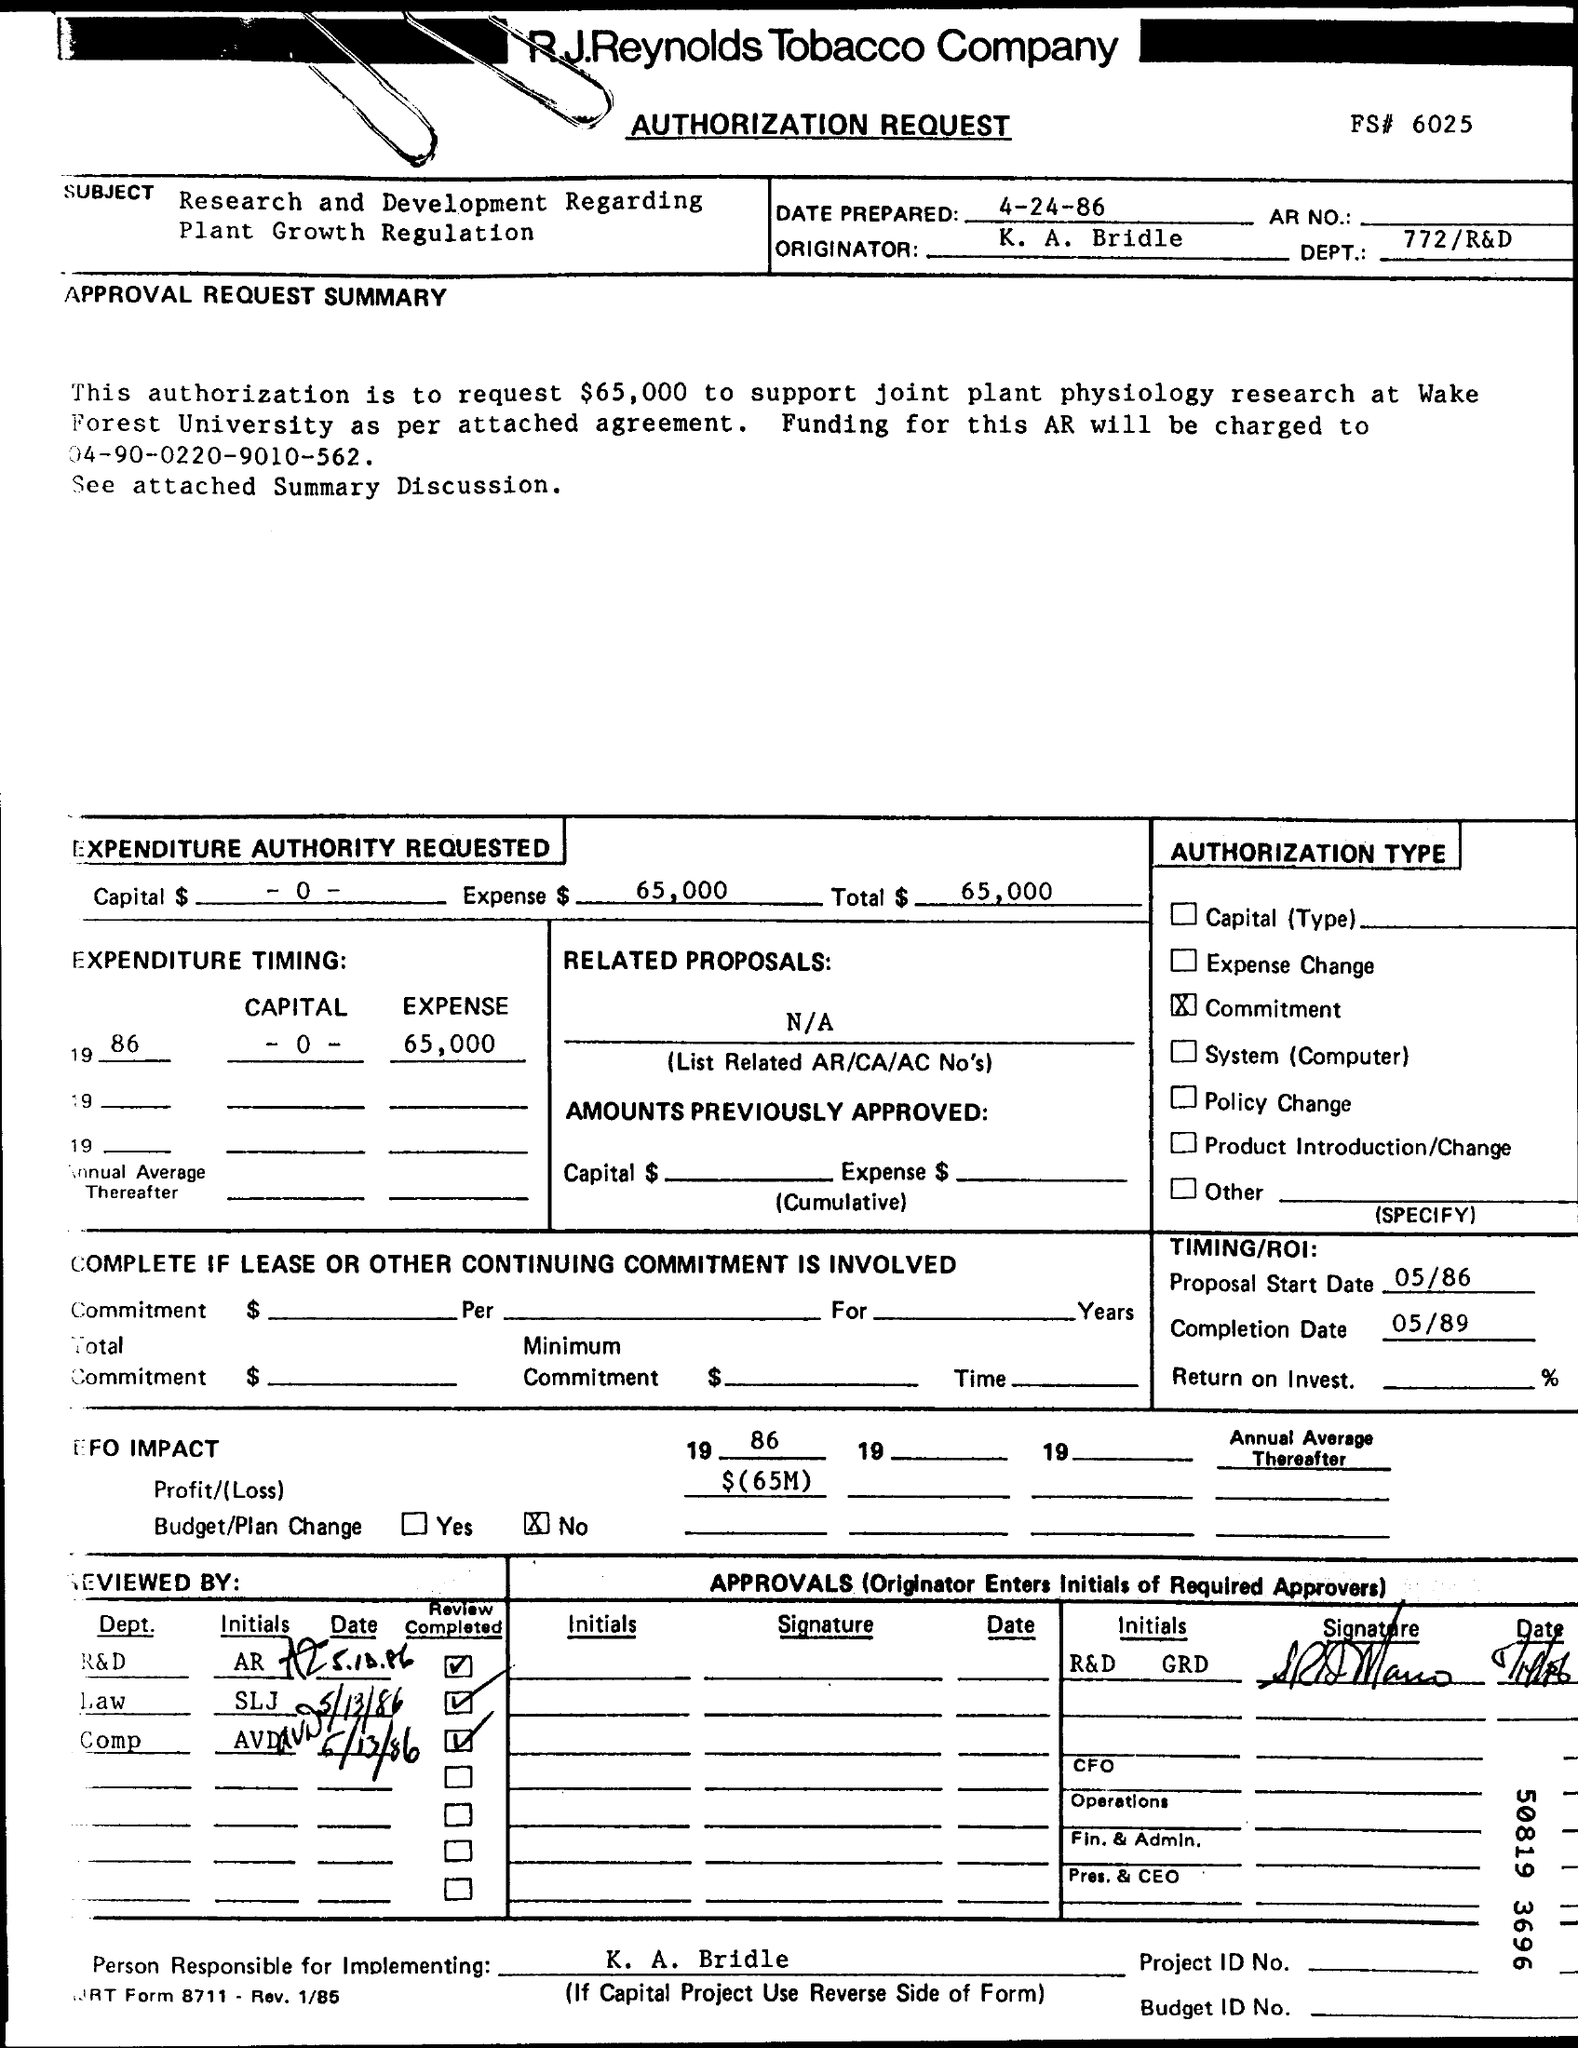What is the Company Name ?
Make the answer very short. R.J.Reynolds Tobacco Company. When it is prepared ?
Provide a short and direct response. 4-24-86. What is the DEPT Number ?
Provide a short and direct response. 772/R&D. What is the Proposal start date ?
Offer a very short reply. 05/86. When is the Completion Date ?
Provide a succinct answer. 05/89. 